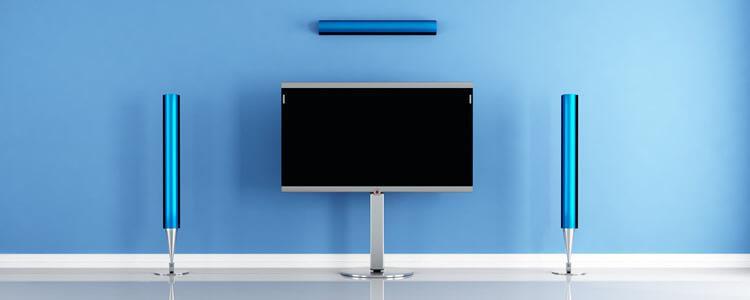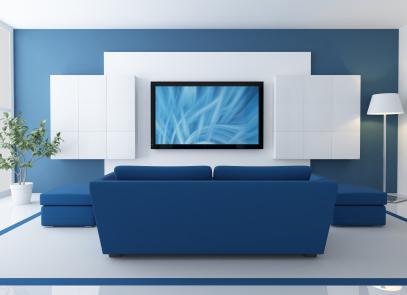The first image is the image on the left, the second image is the image on the right. Examine the images to the left and right. Is the description "At least one of the televisions is turned off." accurate? Answer yes or no. Yes. The first image is the image on the left, the second image is the image on the right. Examine the images to the left and right. Is the description "There is nothing playing on at least one of the screens." accurate? Answer yes or no. Yes. 